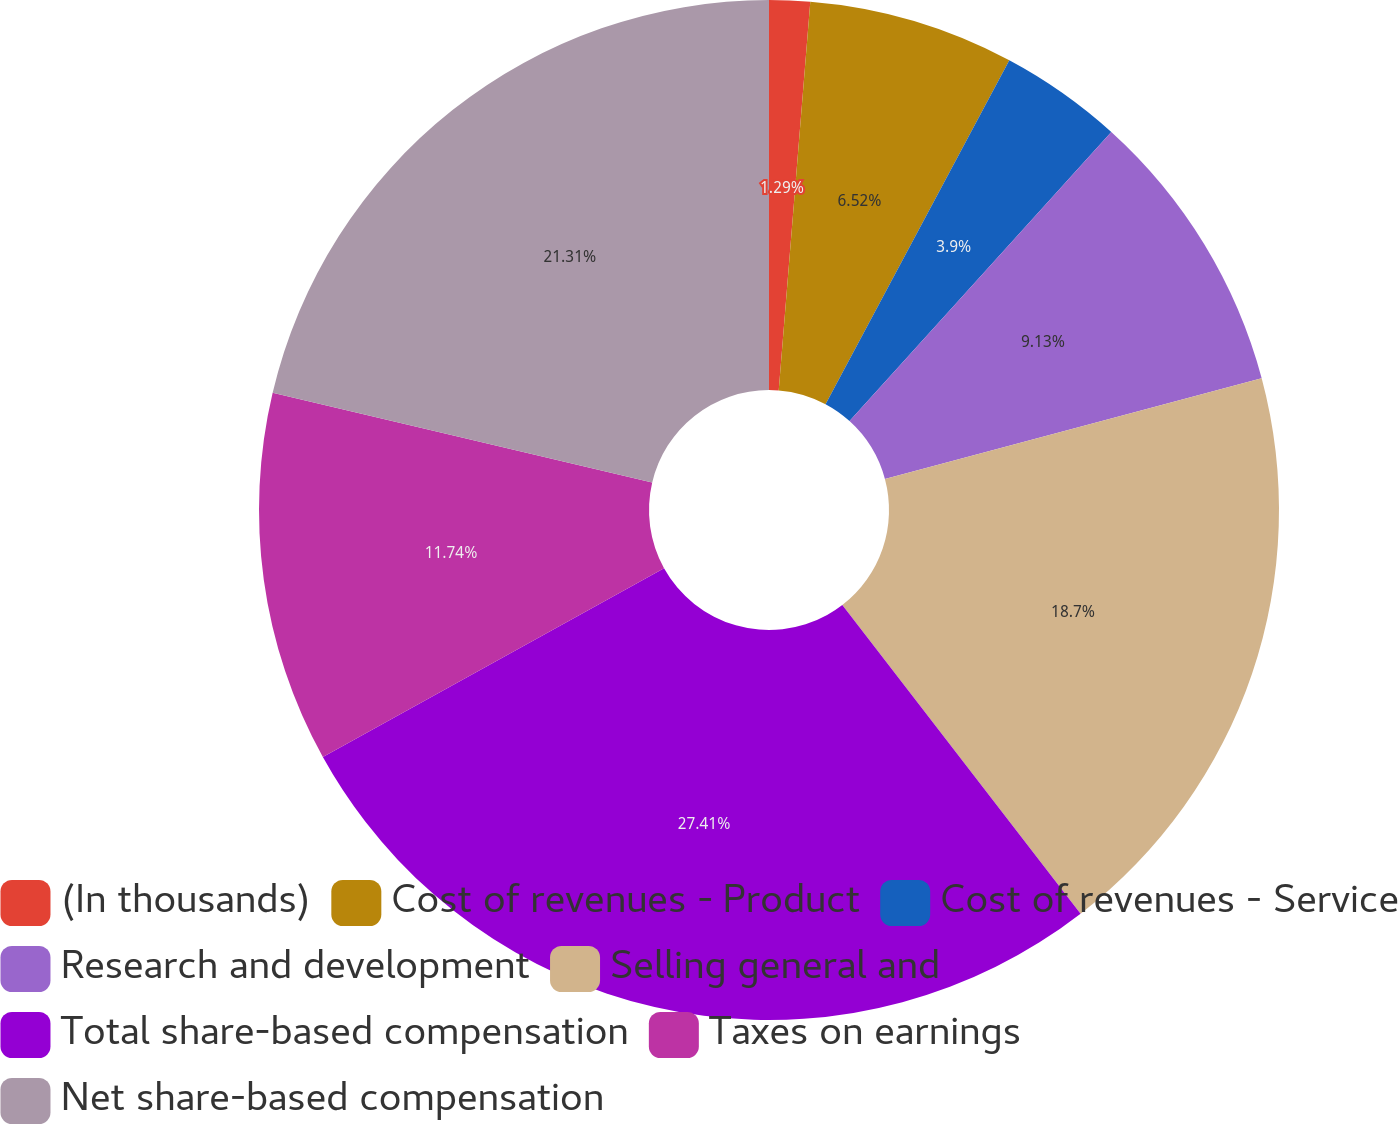<chart> <loc_0><loc_0><loc_500><loc_500><pie_chart><fcel>(In thousands)<fcel>Cost of revenues - Product<fcel>Cost of revenues - Service<fcel>Research and development<fcel>Selling general and<fcel>Total share-based compensation<fcel>Taxes on earnings<fcel>Net share-based compensation<nl><fcel>1.29%<fcel>6.52%<fcel>3.9%<fcel>9.13%<fcel>18.7%<fcel>27.41%<fcel>11.74%<fcel>21.31%<nl></chart> 